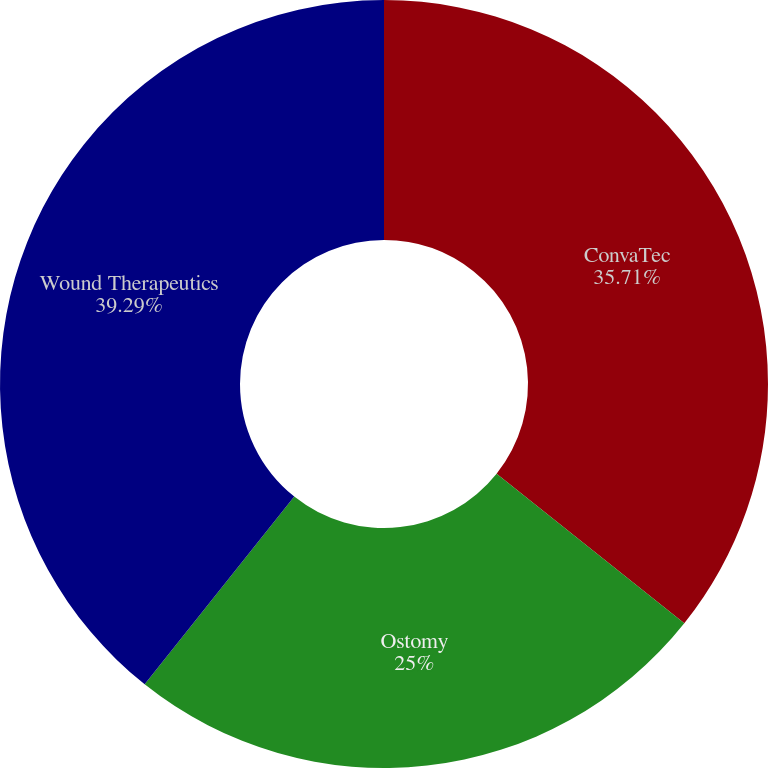<chart> <loc_0><loc_0><loc_500><loc_500><pie_chart><fcel>ConvaTec<fcel>Ostomy<fcel>Wound Therapeutics<nl><fcel>35.71%<fcel>25.0%<fcel>39.29%<nl></chart> 